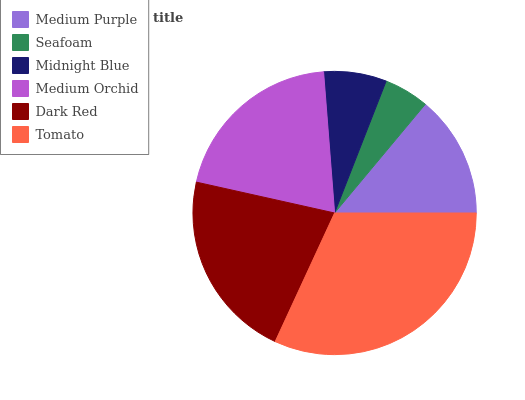Is Seafoam the minimum?
Answer yes or no. Yes. Is Tomato the maximum?
Answer yes or no. Yes. Is Midnight Blue the minimum?
Answer yes or no. No. Is Midnight Blue the maximum?
Answer yes or no. No. Is Midnight Blue greater than Seafoam?
Answer yes or no. Yes. Is Seafoam less than Midnight Blue?
Answer yes or no. Yes. Is Seafoam greater than Midnight Blue?
Answer yes or no. No. Is Midnight Blue less than Seafoam?
Answer yes or no. No. Is Medium Orchid the high median?
Answer yes or no. Yes. Is Medium Purple the low median?
Answer yes or no. Yes. Is Tomato the high median?
Answer yes or no. No. Is Medium Orchid the low median?
Answer yes or no. No. 